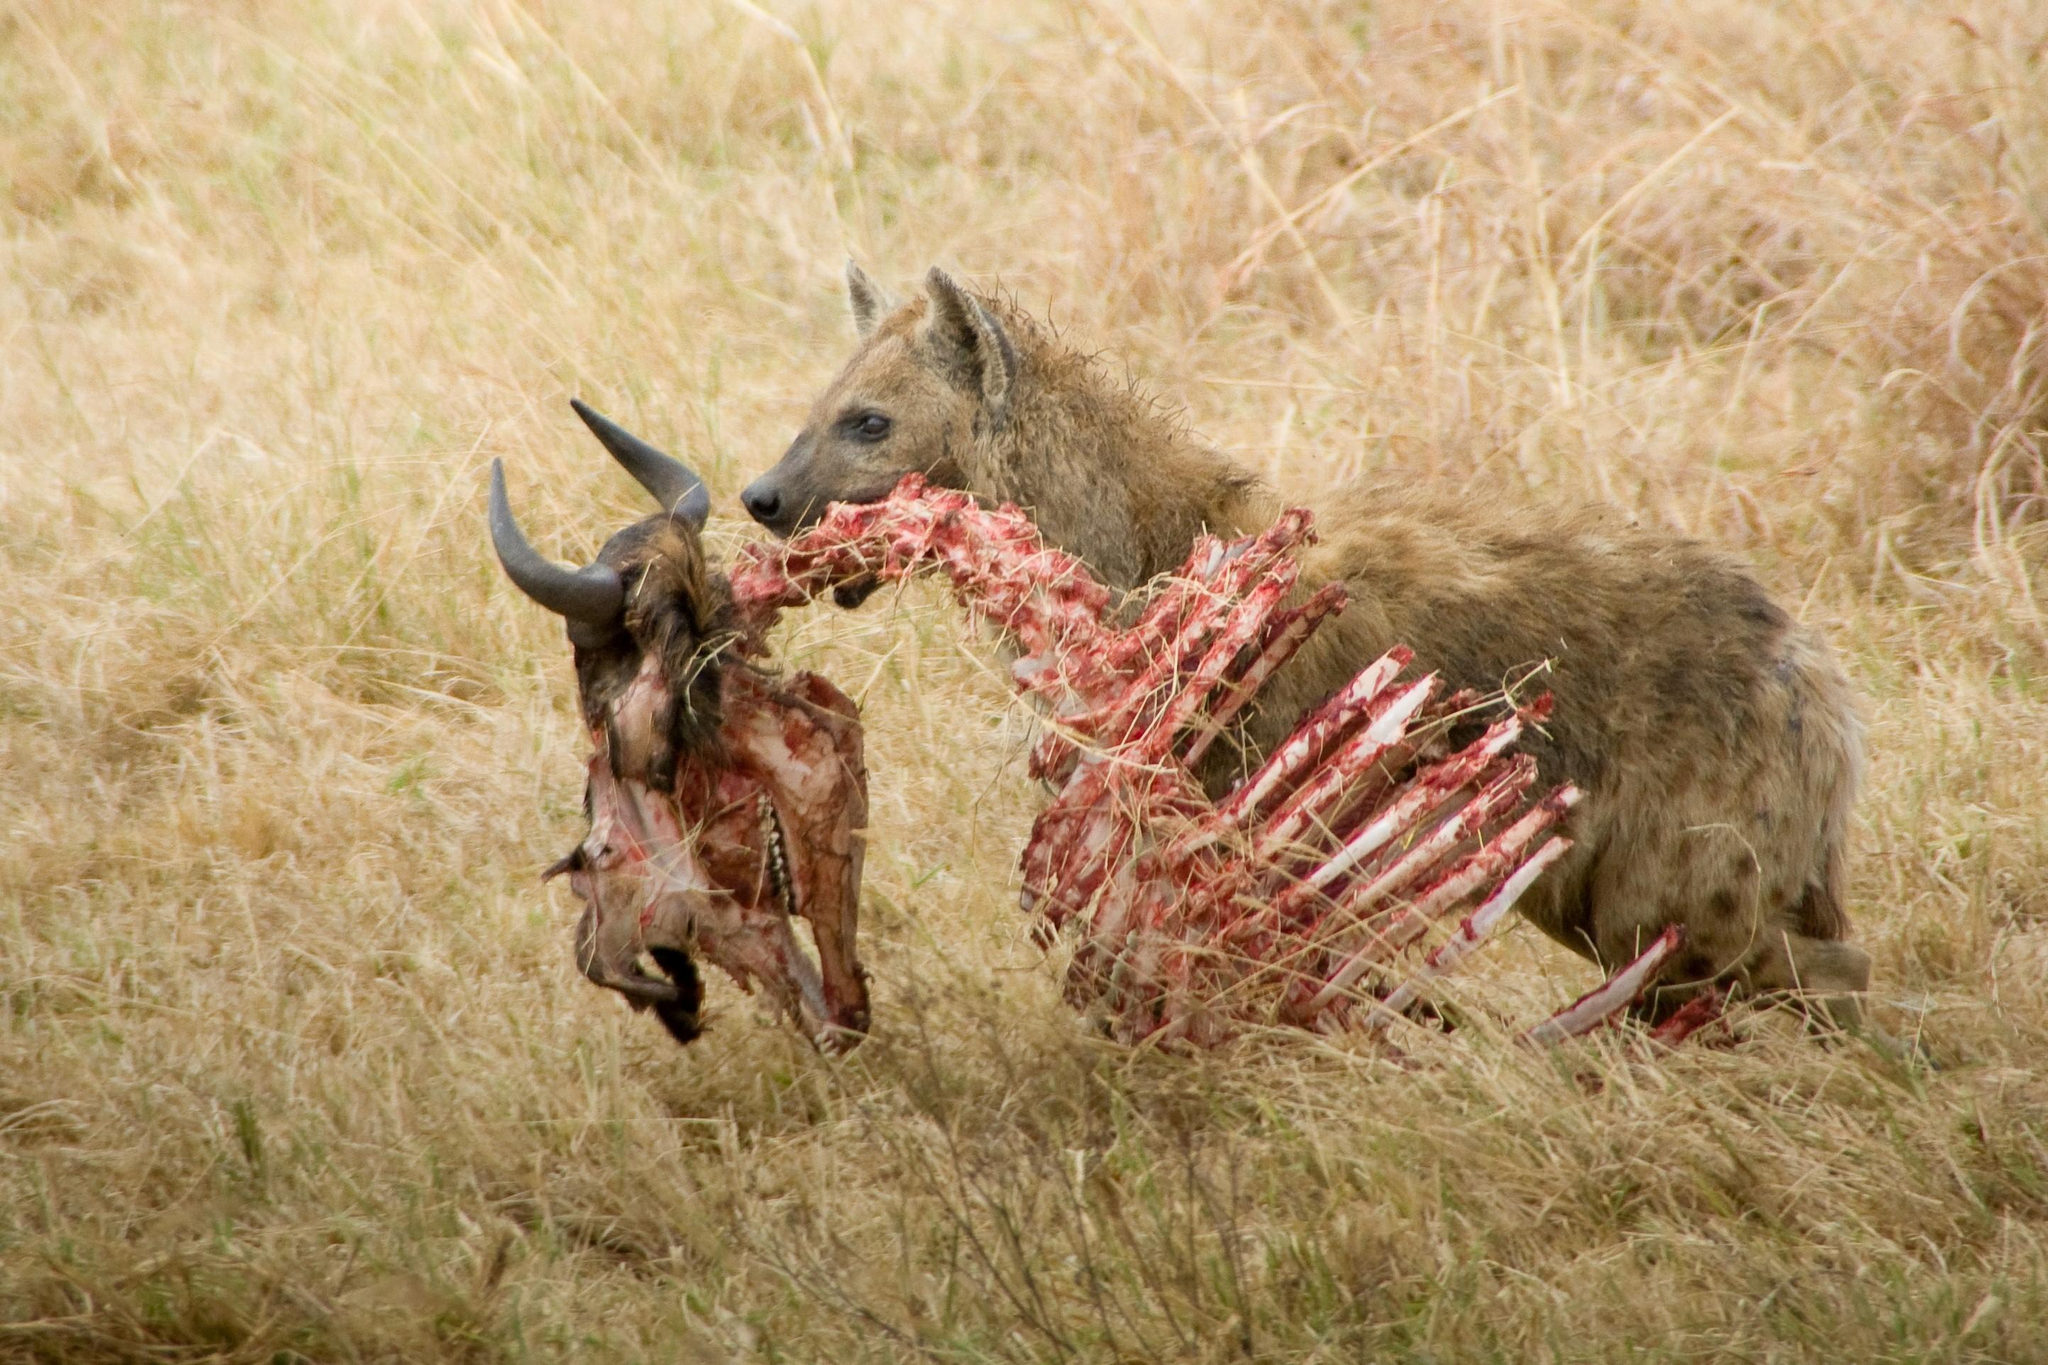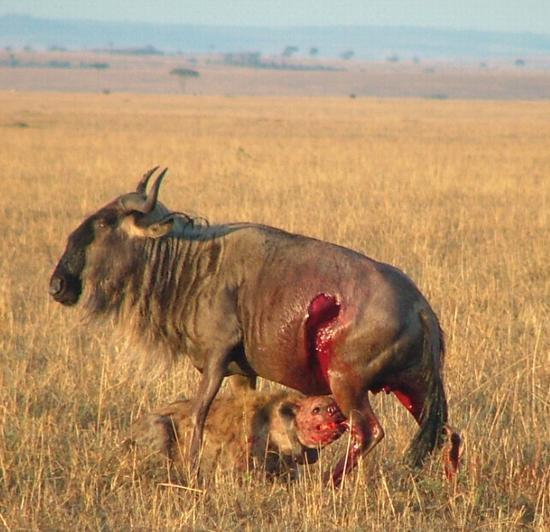The first image is the image on the left, the second image is the image on the right. For the images shown, is this caption "There is no more than one hyena in the right image." true? Answer yes or no. Yes. 